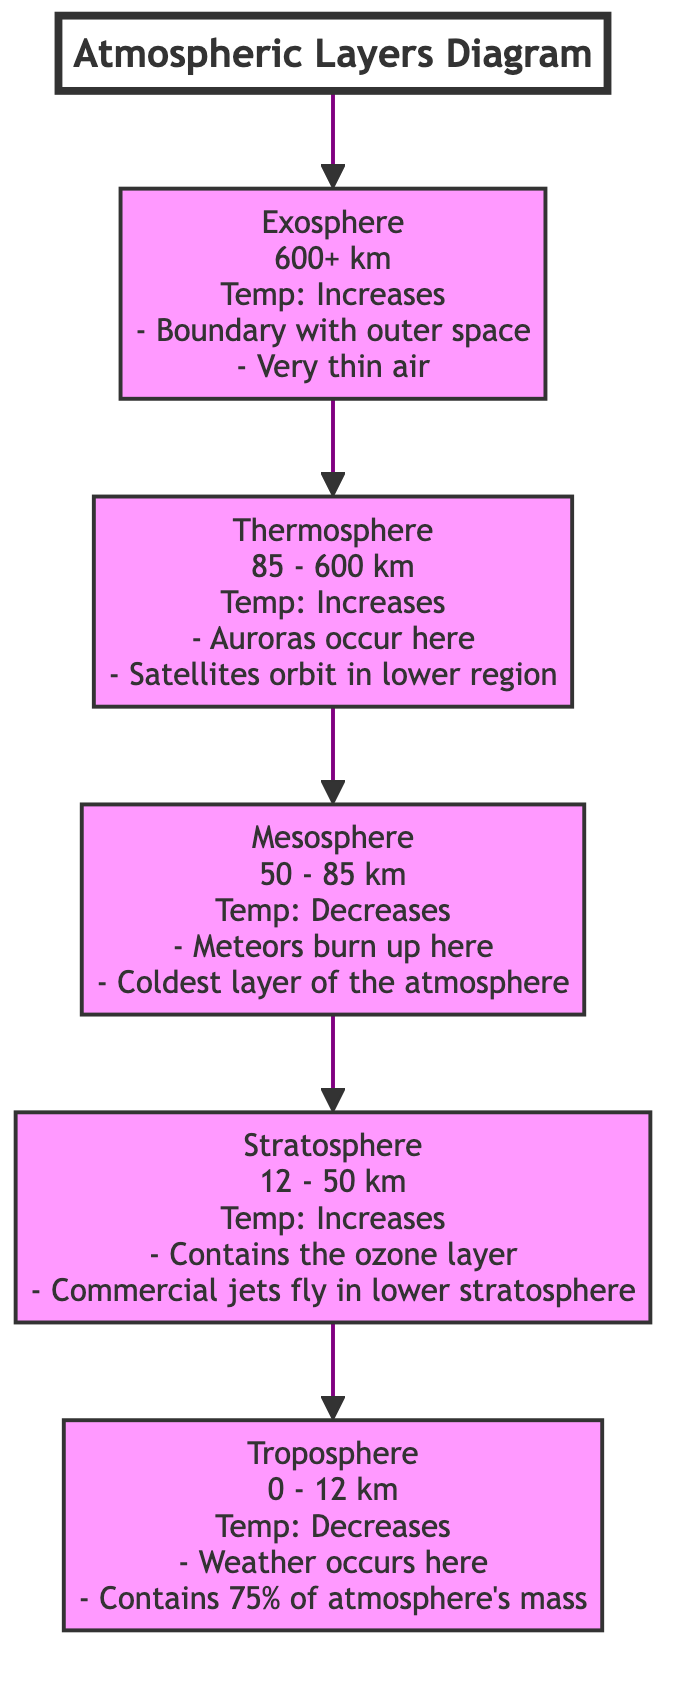What is the temperature variation in the troposphere? The troposphere's temperature decreases, as indicated in the diagram where it specifically states "Temp: Decreases".
Answer: Decreases How many layers of the atmosphere are represented in the diagram? By counting the individual layers listed in the diagram—troposphere, stratosphere, mesosphere, thermosphere, and exosphere—there are five distinct layers.
Answer: 5 What occurs in the mesosphere? The diagram notes that meteors burn up in the mesosphere, making this the primary phenomenon associated with this layer.
Answer: Meteors burn up Which layer contains the ozone layer? According to the diagram, the stratosphere specifically mentions containing the ozone layer, identifying it as a key characteristic of this atmospheric layer.
Answer: Stratosphere What is the upper boundary of the thermosphere? The upper limit of the thermosphere is indicated in the diagram as 600 km, which is clearly labeled next to the thermosphere description.
Answer: 600 km Why do satellites orbit in the thermosphere? The diagram explains that satellites are found in the lower region of the thermosphere, suggesting that the conditions, including thin air and altitude, facilitate satellite operations in this layer.
Answer: Auroras occur here What percentage of the atmosphere's mass is found in the troposphere? The diagram states that the troposphere contains 75% of the atmosphere's mass, providing a direct answer to this inquiry.
Answer: 75% What happens to temperature as you move from the stratosphere to the mesosphere? The diagram indicates that the temperature decreases from the stratosphere to the mesosphere, as detailed in the descriptions of both layers.
Answer: Decreases At what altitude does the troposphere end? The troposphere's upper limit is marked at 12 km in the diagram, which clearly indicates where this layer of the atmosphere stops.
Answer: 12 km 